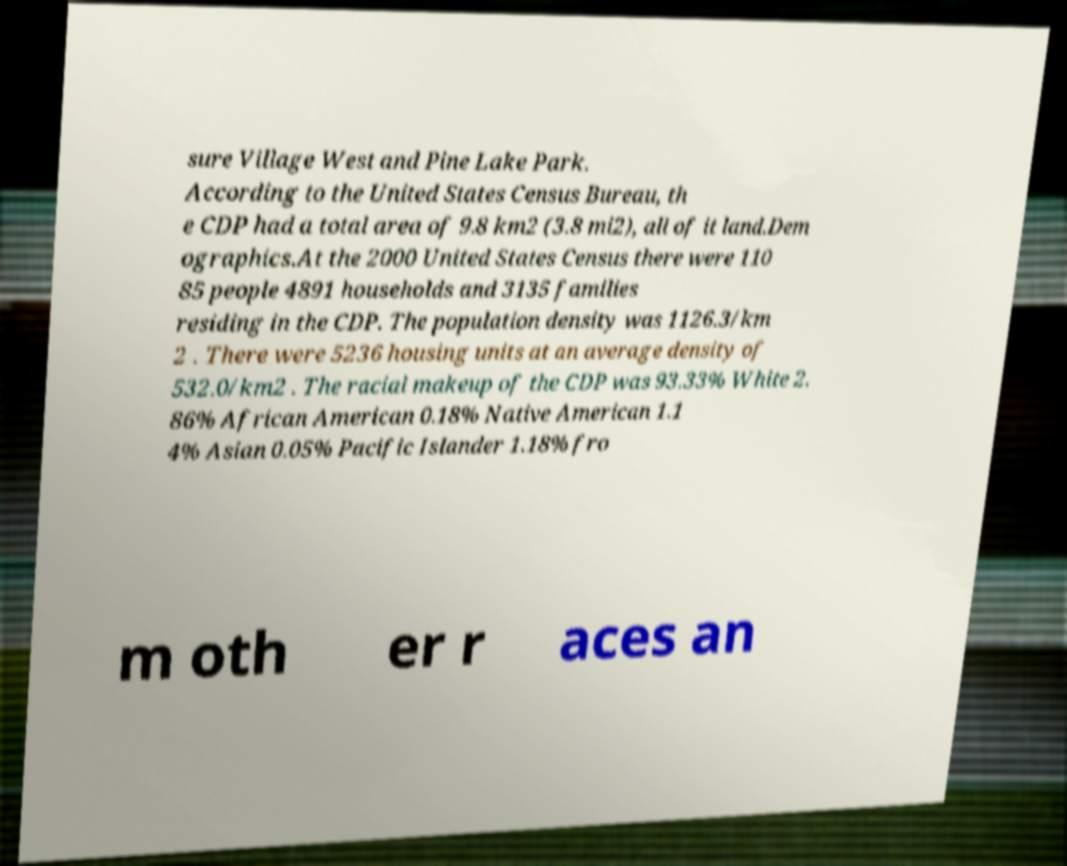I need the written content from this picture converted into text. Can you do that? sure Village West and Pine Lake Park. According to the United States Census Bureau, th e CDP had a total area of 9.8 km2 (3.8 mi2), all of it land.Dem ographics.At the 2000 United States Census there were 110 85 people 4891 households and 3135 families residing in the CDP. The population density was 1126.3/km 2 . There were 5236 housing units at an average density of 532.0/km2 . The racial makeup of the CDP was 93.33% White 2. 86% African American 0.18% Native American 1.1 4% Asian 0.05% Pacific Islander 1.18% fro m oth er r aces an 